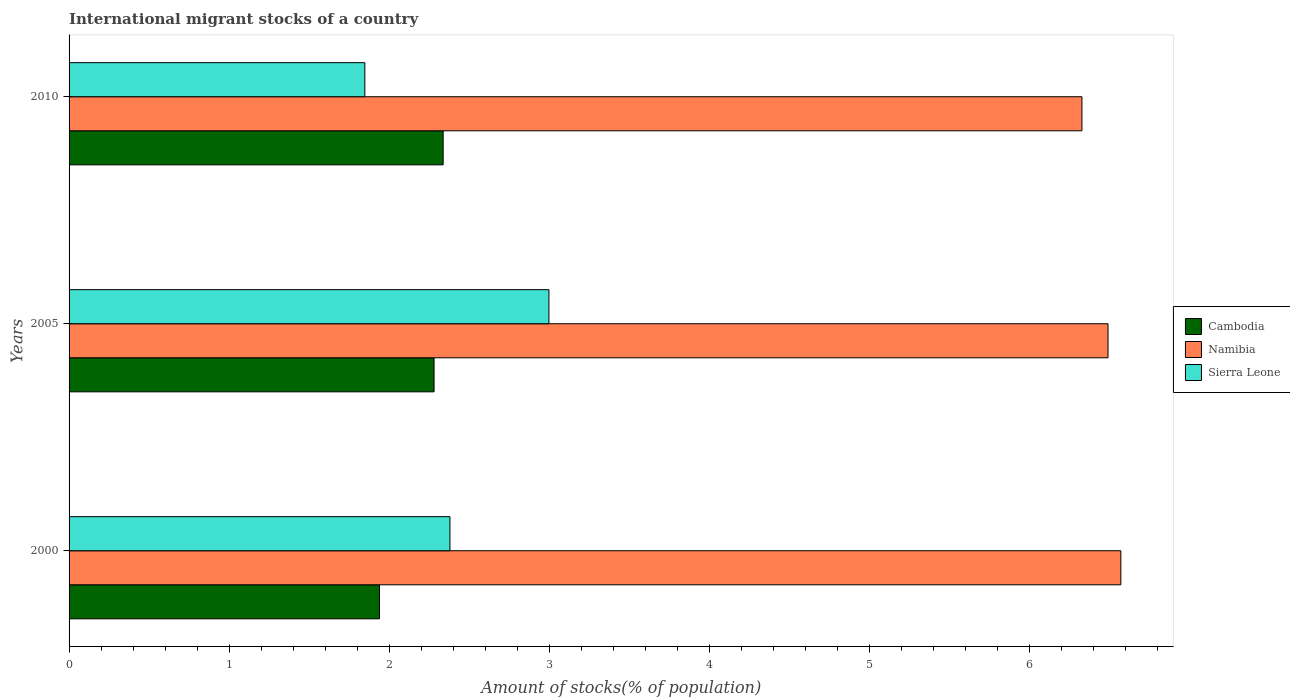Are the number of bars on each tick of the Y-axis equal?
Provide a succinct answer. Yes. How many bars are there on the 1st tick from the bottom?
Provide a succinct answer. 3. In how many cases, is the number of bars for a given year not equal to the number of legend labels?
Ensure brevity in your answer.  0. What is the amount of stocks in in Sierra Leone in 2010?
Give a very brief answer. 1.85. Across all years, what is the maximum amount of stocks in in Namibia?
Keep it short and to the point. 6.57. Across all years, what is the minimum amount of stocks in in Sierra Leone?
Keep it short and to the point. 1.85. In which year was the amount of stocks in in Cambodia maximum?
Provide a succinct answer. 2010. What is the total amount of stocks in in Namibia in the graph?
Ensure brevity in your answer.  19.4. What is the difference between the amount of stocks in in Cambodia in 2000 and that in 2010?
Your answer should be compact. -0.4. What is the difference between the amount of stocks in in Sierra Leone in 2005 and the amount of stocks in in Namibia in 2000?
Provide a succinct answer. -3.57. What is the average amount of stocks in in Namibia per year?
Your answer should be very brief. 6.47. In the year 2000, what is the difference between the amount of stocks in in Cambodia and amount of stocks in in Namibia?
Offer a terse response. -4.63. In how many years, is the amount of stocks in in Namibia greater than 6.4 %?
Ensure brevity in your answer.  2. What is the ratio of the amount of stocks in in Sierra Leone in 2000 to that in 2010?
Your answer should be compact. 1.29. Is the amount of stocks in in Sierra Leone in 2000 less than that in 2010?
Make the answer very short. No. What is the difference between the highest and the second highest amount of stocks in in Namibia?
Your answer should be very brief. 0.08. What is the difference between the highest and the lowest amount of stocks in in Cambodia?
Your response must be concise. 0.4. Is the sum of the amount of stocks in in Sierra Leone in 2000 and 2010 greater than the maximum amount of stocks in in Cambodia across all years?
Make the answer very short. Yes. What does the 1st bar from the top in 2005 represents?
Your response must be concise. Sierra Leone. What does the 2nd bar from the bottom in 2010 represents?
Give a very brief answer. Namibia. How many years are there in the graph?
Offer a very short reply. 3. What is the difference between two consecutive major ticks on the X-axis?
Give a very brief answer. 1. Are the values on the major ticks of X-axis written in scientific E-notation?
Make the answer very short. No. Does the graph contain grids?
Offer a terse response. No. How many legend labels are there?
Ensure brevity in your answer.  3. What is the title of the graph?
Offer a terse response. International migrant stocks of a country. Does "Netherlands" appear as one of the legend labels in the graph?
Offer a terse response. No. What is the label or title of the X-axis?
Your response must be concise. Amount of stocks(% of population). What is the Amount of stocks(% of population) of Cambodia in 2000?
Your answer should be compact. 1.94. What is the Amount of stocks(% of population) in Namibia in 2000?
Your answer should be very brief. 6.57. What is the Amount of stocks(% of population) in Sierra Leone in 2000?
Give a very brief answer. 2.38. What is the Amount of stocks(% of population) in Cambodia in 2005?
Offer a terse response. 2.28. What is the Amount of stocks(% of population) of Namibia in 2005?
Your answer should be compact. 6.49. What is the Amount of stocks(% of population) in Sierra Leone in 2005?
Ensure brevity in your answer.  3. What is the Amount of stocks(% of population) in Cambodia in 2010?
Offer a very short reply. 2.34. What is the Amount of stocks(% of population) of Namibia in 2010?
Ensure brevity in your answer.  6.33. What is the Amount of stocks(% of population) in Sierra Leone in 2010?
Provide a succinct answer. 1.85. Across all years, what is the maximum Amount of stocks(% of population) of Cambodia?
Ensure brevity in your answer.  2.34. Across all years, what is the maximum Amount of stocks(% of population) in Namibia?
Offer a terse response. 6.57. Across all years, what is the maximum Amount of stocks(% of population) in Sierra Leone?
Provide a short and direct response. 3. Across all years, what is the minimum Amount of stocks(% of population) of Cambodia?
Your answer should be very brief. 1.94. Across all years, what is the minimum Amount of stocks(% of population) of Namibia?
Make the answer very short. 6.33. Across all years, what is the minimum Amount of stocks(% of population) in Sierra Leone?
Offer a terse response. 1.85. What is the total Amount of stocks(% of population) in Cambodia in the graph?
Your answer should be compact. 6.56. What is the total Amount of stocks(% of population) in Namibia in the graph?
Offer a terse response. 19.4. What is the total Amount of stocks(% of population) of Sierra Leone in the graph?
Provide a succinct answer. 7.23. What is the difference between the Amount of stocks(% of population) of Cambodia in 2000 and that in 2005?
Offer a very short reply. -0.34. What is the difference between the Amount of stocks(% of population) in Namibia in 2000 and that in 2005?
Give a very brief answer. 0.08. What is the difference between the Amount of stocks(% of population) of Sierra Leone in 2000 and that in 2005?
Keep it short and to the point. -0.62. What is the difference between the Amount of stocks(% of population) of Cambodia in 2000 and that in 2010?
Provide a short and direct response. -0.4. What is the difference between the Amount of stocks(% of population) in Namibia in 2000 and that in 2010?
Give a very brief answer. 0.24. What is the difference between the Amount of stocks(% of population) in Sierra Leone in 2000 and that in 2010?
Give a very brief answer. 0.53. What is the difference between the Amount of stocks(% of population) in Cambodia in 2005 and that in 2010?
Provide a succinct answer. -0.06. What is the difference between the Amount of stocks(% of population) of Namibia in 2005 and that in 2010?
Make the answer very short. 0.16. What is the difference between the Amount of stocks(% of population) in Sierra Leone in 2005 and that in 2010?
Keep it short and to the point. 1.15. What is the difference between the Amount of stocks(% of population) of Cambodia in 2000 and the Amount of stocks(% of population) of Namibia in 2005?
Give a very brief answer. -4.55. What is the difference between the Amount of stocks(% of population) in Cambodia in 2000 and the Amount of stocks(% of population) in Sierra Leone in 2005?
Offer a terse response. -1.06. What is the difference between the Amount of stocks(% of population) in Namibia in 2000 and the Amount of stocks(% of population) in Sierra Leone in 2005?
Keep it short and to the point. 3.57. What is the difference between the Amount of stocks(% of population) of Cambodia in 2000 and the Amount of stocks(% of population) of Namibia in 2010?
Provide a succinct answer. -4.39. What is the difference between the Amount of stocks(% of population) of Cambodia in 2000 and the Amount of stocks(% of population) of Sierra Leone in 2010?
Your answer should be compact. 0.09. What is the difference between the Amount of stocks(% of population) in Namibia in 2000 and the Amount of stocks(% of population) in Sierra Leone in 2010?
Offer a very short reply. 4.73. What is the difference between the Amount of stocks(% of population) of Cambodia in 2005 and the Amount of stocks(% of population) of Namibia in 2010?
Provide a succinct answer. -4.05. What is the difference between the Amount of stocks(% of population) in Cambodia in 2005 and the Amount of stocks(% of population) in Sierra Leone in 2010?
Provide a short and direct response. 0.43. What is the difference between the Amount of stocks(% of population) in Namibia in 2005 and the Amount of stocks(% of population) in Sierra Leone in 2010?
Keep it short and to the point. 4.65. What is the average Amount of stocks(% of population) of Cambodia per year?
Your response must be concise. 2.19. What is the average Amount of stocks(% of population) in Namibia per year?
Keep it short and to the point. 6.47. What is the average Amount of stocks(% of population) of Sierra Leone per year?
Keep it short and to the point. 2.41. In the year 2000, what is the difference between the Amount of stocks(% of population) in Cambodia and Amount of stocks(% of population) in Namibia?
Give a very brief answer. -4.63. In the year 2000, what is the difference between the Amount of stocks(% of population) of Cambodia and Amount of stocks(% of population) of Sierra Leone?
Provide a short and direct response. -0.44. In the year 2000, what is the difference between the Amount of stocks(% of population) in Namibia and Amount of stocks(% of population) in Sierra Leone?
Give a very brief answer. 4.19. In the year 2005, what is the difference between the Amount of stocks(% of population) in Cambodia and Amount of stocks(% of population) in Namibia?
Provide a short and direct response. -4.21. In the year 2005, what is the difference between the Amount of stocks(% of population) in Cambodia and Amount of stocks(% of population) in Sierra Leone?
Offer a very short reply. -0.72. In the year 2005, what is the difference between the Amount of stocks(% of population) of Namibia and Amount of stocks(% of population) of Sierra Leone?
Offer a very short reply. 3.49. In the year 2010, what is the difference between the Amount of stocks(% of population) of Cambodia and Amount of stocks(% of population) of Namibia?
Provide a succinct answer. -3.99. In the year 2010, what is the difference between the Amount of stocks(% of population) in Cambodia and Amount of stocks(% of population) in Sierra Leone?
Give a very brief answer. 0.49. In the year 2010, what is the difference between the Amount of stocks(% of population) in Namibia and Amount of stocks(% of population) in Sierra Leone?
Ensure brevity in your answer.  4.48. What is the ratio of the Amount of stocks(% of population) of Cambodia in 2000 to that in 2005?
Make the answer very short. 0.85. What is the ratio of the Amount of stocks(% of population) of Namibia in 2000 to that in 2005?
Keep it short and to the point. 1.01. What is the ratio of the Amount of stocks(% of population) of Sierra Leone in 2000 to that in 2005?
Ensure brevity in your answer.  0.79. What is the ratio of the Amount of stocks(% of population) in Cambodia in 2000 to that in 2010?
Your response must be concise. 0.83. What is the ratio of the Amount of stocks(% of population) in Namibia in 2000 to that in 2010?
Provide a succinct answer. 1.04. What is the ratio of the Amount of stocks(% of population) of Sierra Leone in 2000 to that in 2010?
Your answer should be very brief. 1.29. What is the ratio of the Amount of stocks(% of population) of Cambodia in 2005 to that in 2010?
Your response must be concise. 0.98. What is the ratio of the Amount of stocks(% of population) in Namibia in 2005 to that in 2010?
Make the answer very short. 1.03. What is the ratio of the Amount of stocks(% of population) in Sierra Leone in 2005 to that in 2010?
Keep it short and to the point. 1.62. What is the difference between the highest and the second highest Amount of stocks(% of population) of Cambodia?
Your answer should be very brief. 0.06. What is the difference between the highest and the second highest Amount of stocks(% of population) of Namibia?
Your response must be concise. 0.08. What is the difference between the highest and the second highest Amount of stocks(% of population) in Sierra Leone?
Your answer should be very brief. 0.62. What is the difference between the highest and the lowest Amount of stocks(% of population) in Cambodia?
Your response must be concise. 0.4. What is the difference between the highest and the lowest Amount of stocks(% of population) in Namibia?
Provide a succinct answer. 0.24. What is the difference between the highest and the lowest Amount of stocks(% of population) in Sierra Leone?
Give a very brief answer. 1.15. 